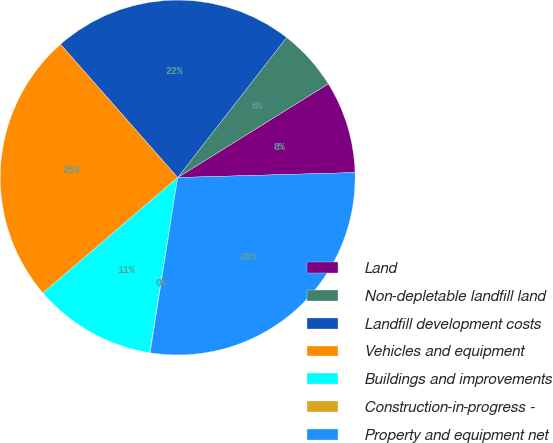<chart> <loc_0><loc_0><loc_500><loc_500><pie_chart><fcel>Land<fcel>Non-depletable landfill land<fcel>Landfill development costs<fcel>Vehicles and equipment<fcel>Buildings and improvements<fcel>Construction-in-progress -<fcel>Property and equipment net<nl><fcel>8.41%<fcel>5.62%<fcel>22.01%<fcel>24.8%<fcel>11.2%<fcel>0.04%<fcel>27.93%<nl></chart> 